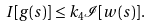<formula> <loc_0><loc_0><loc_500><loc_500>I [ g ( s ) ] \leq k _ { 4 } \mathcal { I } [ w ( s ) ] .</formula> 